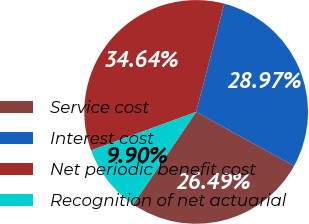<chart> <loc_0><loc_0><loc_500><loc_500><pie_chart><fcel>Service cost<fcel>Interest cost<fcel>Net periodic benefit cost<fcel>Recognition of net actuarial<nl><fcel>26.49%<fcel>28.97%<fcel>34.64%<fcel>9.9%<nl></chart> 